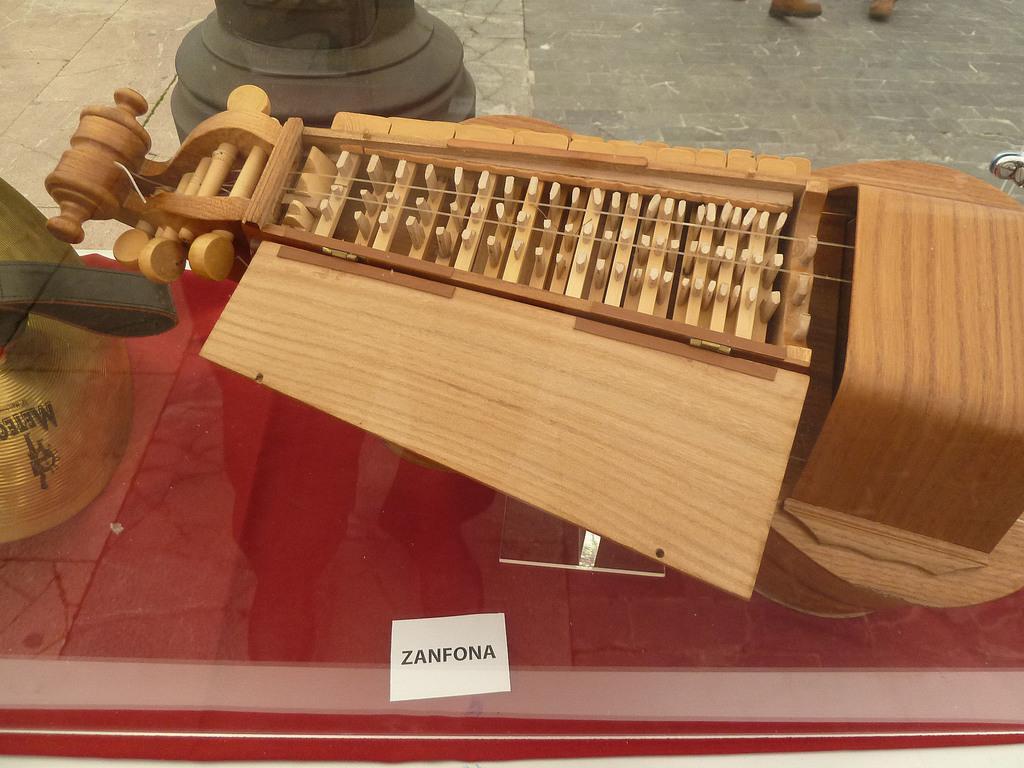Please provide a concise description of this image. This image consists of some musical instrument. It is made from wood. 